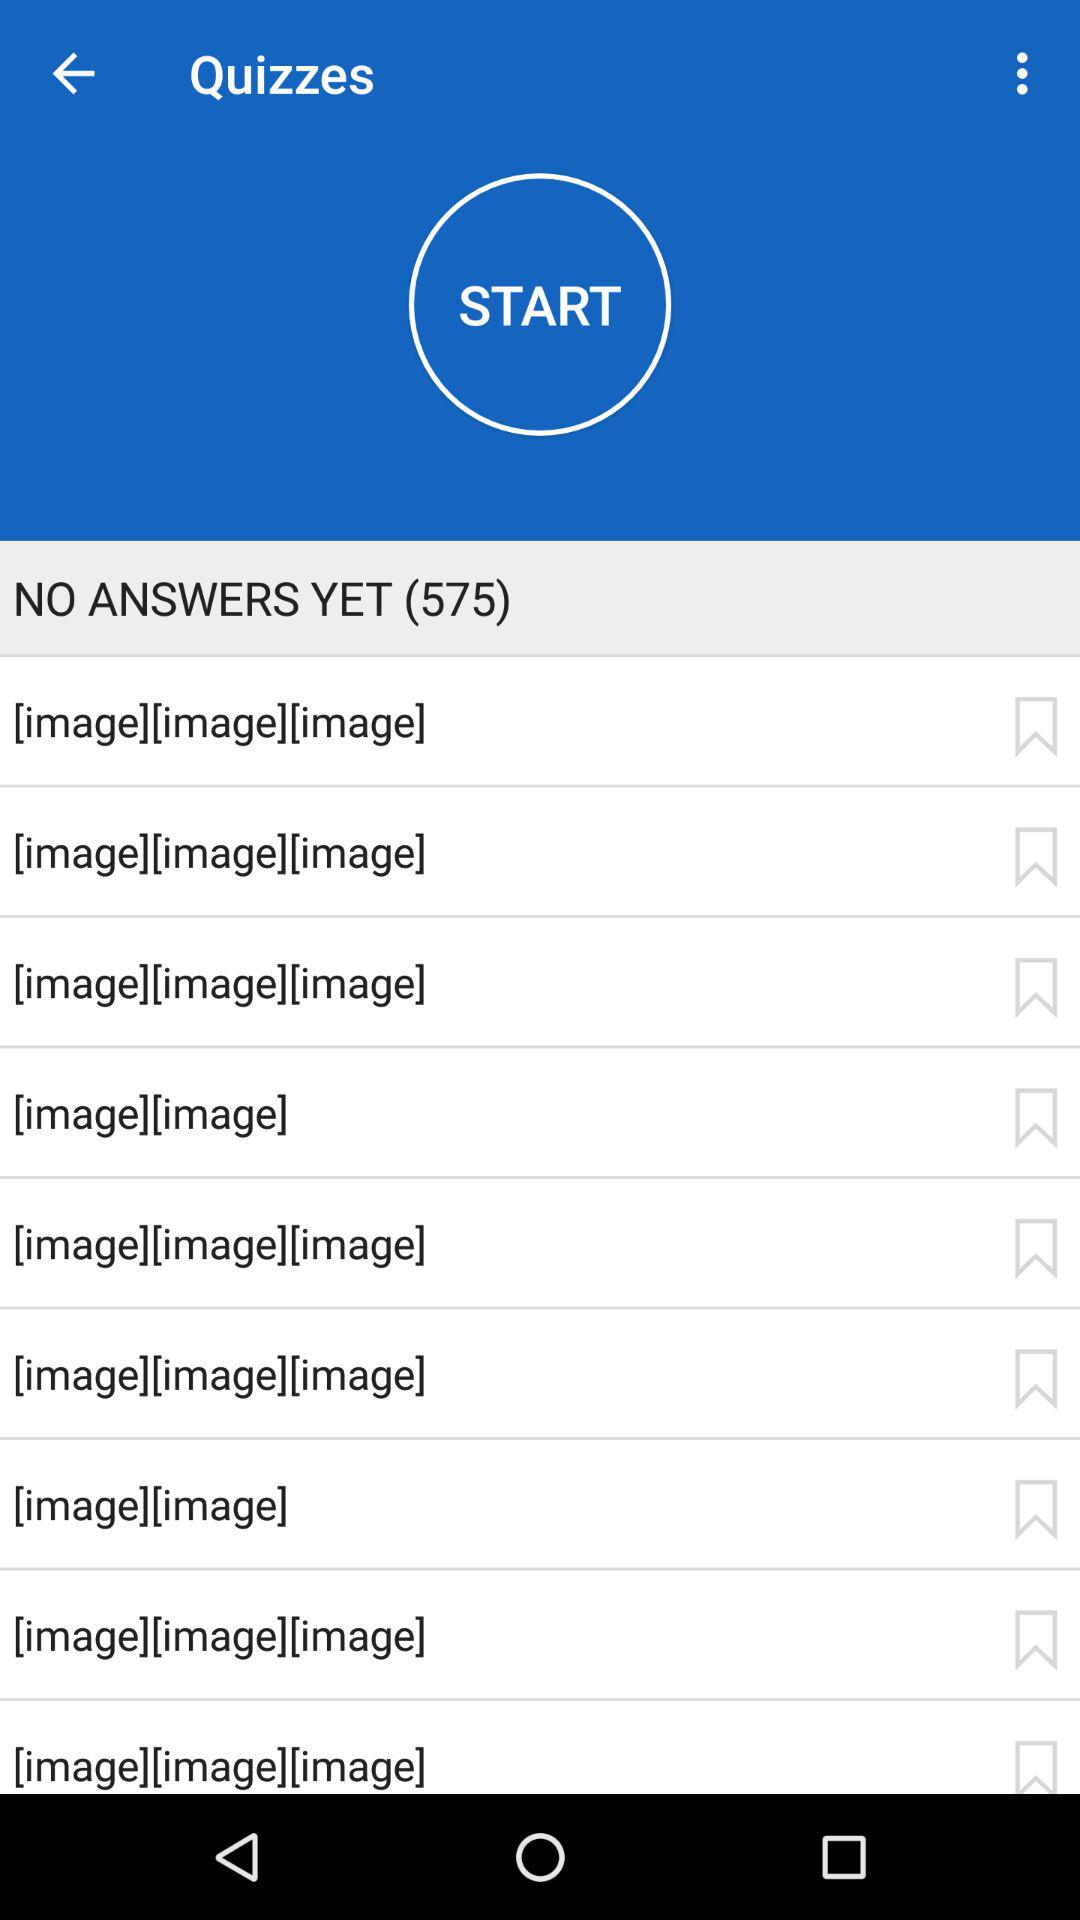How many quizzes are still unanswered? There are 575 unanswered quizzes. 